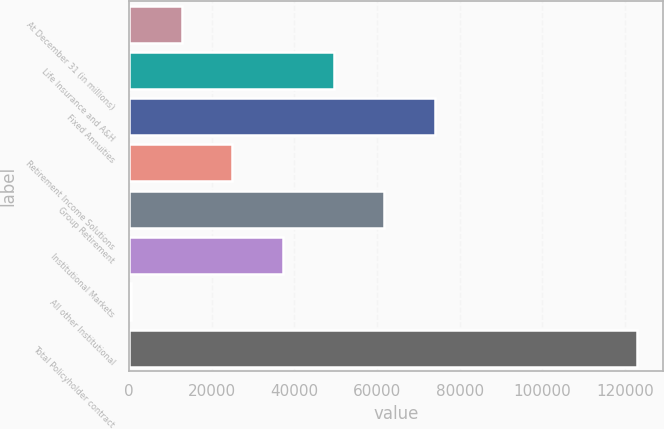Convert chart to OTSL. <chart><loc_0><loc_0><loc_500><loc_500><bar_chart><fcel>At December 31 (in millions)<fcel>Life Insurance and A&H<fcel>Fixed Annuities<fcel>Retirement Income Solutions<fcel>Group Retirement<fcel>Institutional Markets<fcel>All other Institutional<fcel>Total Policyholder contract<nl><fcel>12756.1<fcel>49497.4<fcel>73991.6<fcel>25003.2<fcel>61744.5<fcel>37250.3<fcel>509<fcel>122980<nl></chart> 